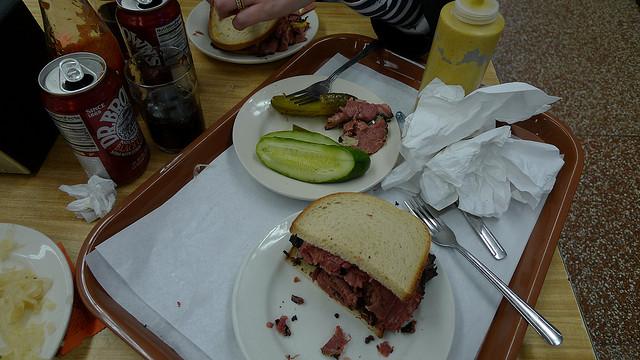Have these napkins been used?
Write a very short answer. Yes. What's for lunch?
Be succinct. Sandwich. What is right to the cup?
Short answer required. Sandwich. Are utensils shown?
Keep it brief. Yes. What drink is in the can?
Concise answer only. Soda. What brand of beer is pictured?
Write a very short answer. Dr browns. What is the brand of root beer?
Give a very brief answer. Dr brown. What food is on the side plate?
Concise answer only. Pickles. What kind of condiment is on the table?
Keep it brief. Mustard. Is the white material biodegradable?
Quick response, please. Yes. 